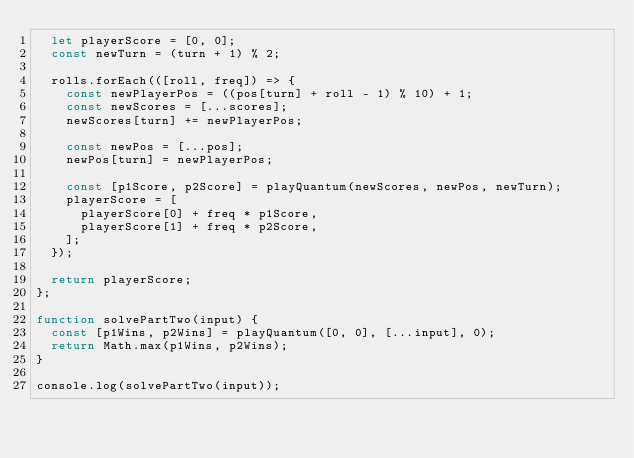<code> <loc_0><loc_0><loc_500><loc_500><_JavaScript_>  let playerScore = [0, 0];
  const newTurn = (turn + 1) % 2;

  rolls.forEach(([roll, freq]) => {
    const newPlayerPos = ((pos[turn] + roll - 1) % 10) + 1;
    const newScores = [...scores];
    newScores[turn] += newPlayerPos;

    const newPos = [...pos];
    newPos[turn] = newPlayerPos;

    const [p1Score, p2Score] = playQuantum(newScores, newPos, newTurn);
    playerScore = [
      playerScore[0] + freq * p1Score,
      playerScore[1] + freq * p2Score,
    ];
  });

  return playerScore;
};

function solvePartTwo(input) {
  const [p1Wins, p2Wins] = playQuantum([0, 0], [...input], 0);
  return Math.max(p1Wins, p2Wins);
}

console.log(solvePartTwo(input));
</code> 